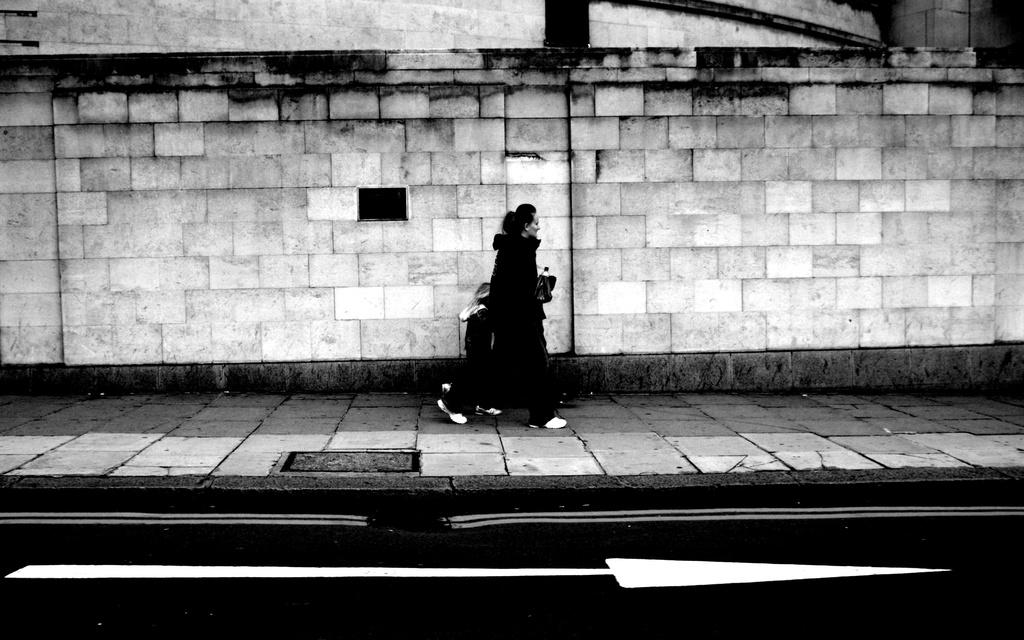What is located at the bottom of the image? There is a road at the bottom of the image. What are the people in the image doing? People are walking on a footpath in the middle of the image. What can be seen in the background of the image? There is a brick wall in the background of the image. What type of disease is being treated in the image? There is no indication of a disease or treatment in the image. What color is the vest worn by the person walking on the footpath? There is no information about a vest or its color in the image. 